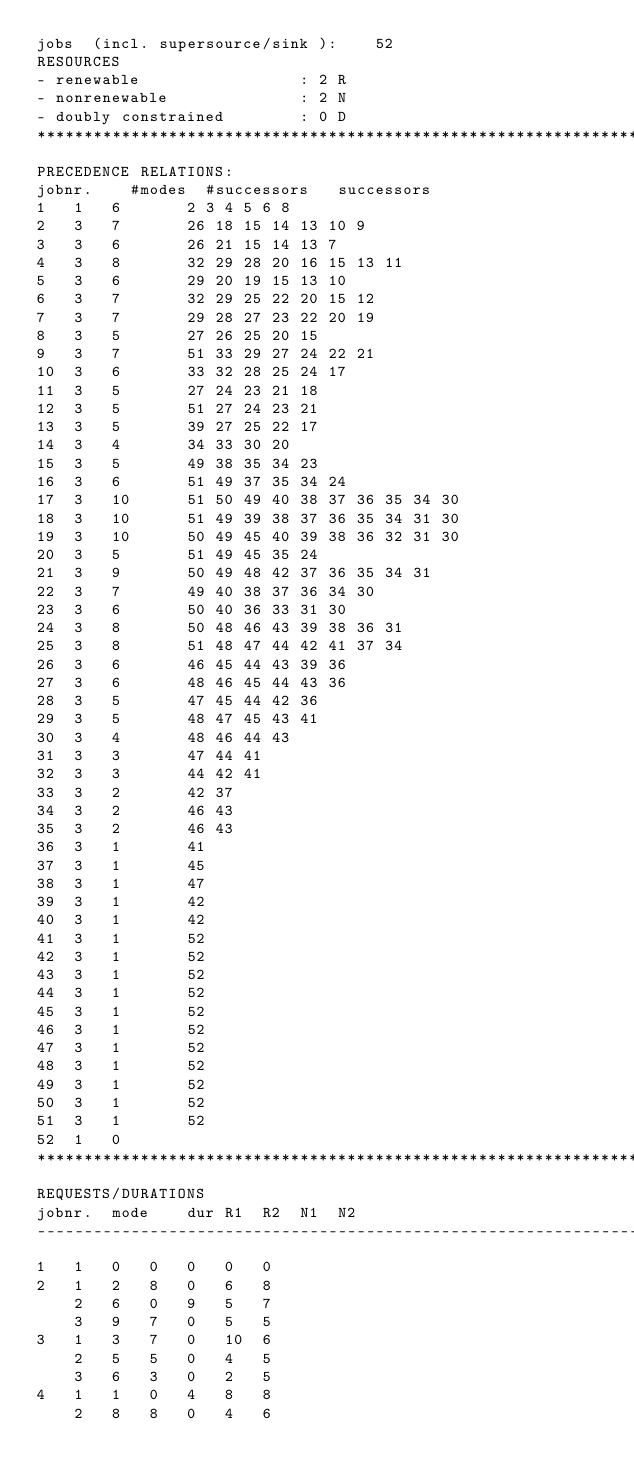Convert code to text. <code><loc_0><loc_0><loc_500><loc_500><_ObjectiveC_>jobs  (incl. supersource/sink ):	52
RESOURCES
- renewable                 : 2 R
- nonrenewable              : 2 N
- doubly constrained        : 0 D
************************************************************************
PRECEDENCE RELATIONS:
jobnr.    #modes  #successors   successors
1	1	6		2 3 4 5 6 8 
2	3	7		26 18 15 14 13 10 9 
3	3	6		26 21 15 14 13 7 
4	3	8		32 29 28 20 16 15 13 11 
5	3	6		29 20 19 15 13 10 
6	3	7		32 29 25 22 20 15 12 
7	3	7		29 28 27 23 22 20 19 
8	3	5		27 26 25 20 15 
9	3	7		51 33 29 27 24 22 21 
10	3	6		33 32 28 25 24 17 
11	3	5		27 24 23 21 18 
12	3	5		51 27 24 23 21 
13	3	5		39 27 25 22 17 
14	3	4		34 33 30 20 
15	3	5		49 38 35 34 23 
16	3	6		51 49 37 35 34 24 
17	3	10		51 50 49 40 38 37 36 35 34 30 
18	3	10		51 49 39 38 37 36 35 34 31 30 
19	3	10		50 49 45 40 39 38 36 32 31 30 
20	3	5		51 49 45 35 24 
21	3	9		50 49 48 42 37 36 35 34 31 
22	3	7		49 40 38 37 36 34 30 
23	3	6		50 40 36 33 31 30 
24	3	8		50 48 46 43 39 38 36 31 
25	3	8		51 48 47 44 42 41 37 34 
26	3	6		46 45 44 43 39 36 
27	3	6		48 46 45 44 43 36 
28	3	5		47 45 44 42 36 
29	3	5		48 47 45 43 41 
30	3	4		48 46 44 43 
31	3	3		47 44 41 
32	3	3		44 42 41 
33	3	2		42 37 
34	3	2		46 43 
35	3	2		46 43 
36	3	1		41 
37	3	1		45 
38	3	1		47 
39	3	1		42 
40	3	1		42 
41	3	1		52 
42	3	1		52 
43	3	1		52 
44	3	1		52 
45	3	1		52 
46	3	1		52 
47	3	1		52 
48	3	1		52 
49	3	1		52 
50	3	1		52 
51	3	1		52 
52	1	0		
************************************************************************
REQUESTS/DURATIONS
jobnr.	mode	dur	R1	R2	N1	N2	
------------------------------------------------------------------------
1	1	0	0	0	0	0	
2	1	2	8	0	6	8	
	2	6	0	9	5	7	
	3	9	7	0	5	5	
3	1	3	7	0	10	6	
	2	5	5	0	4	5	
	3	6	3	0	2	5	
4	1	1	0	4	8	8	
	2	8	8	0	4	6	</code> 